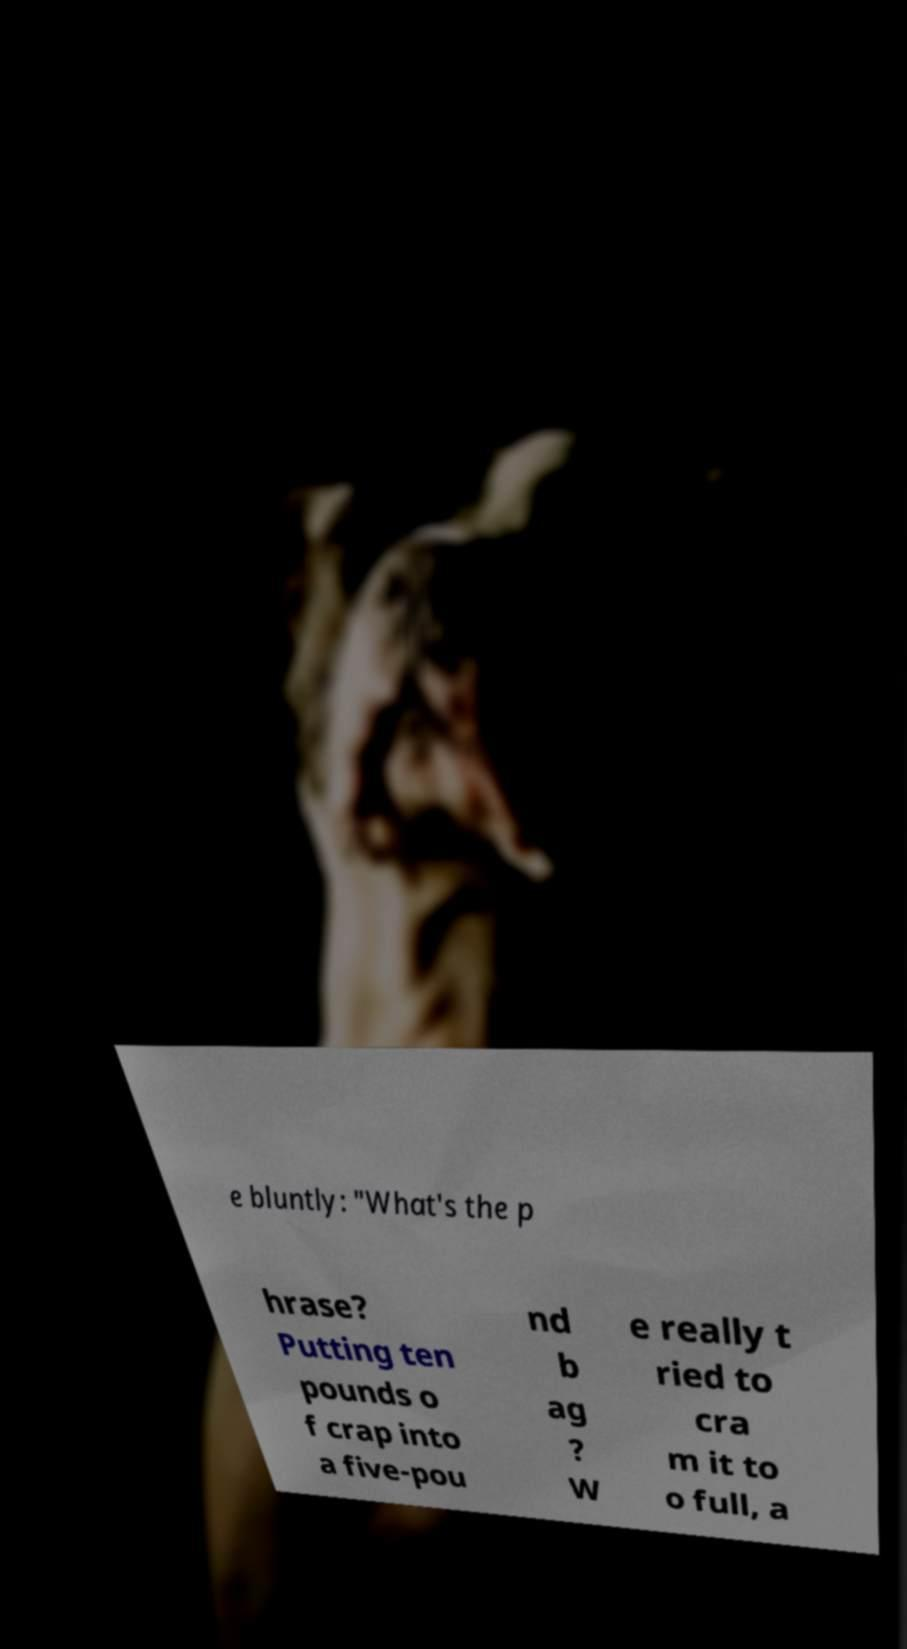Please identify and transcribe the text found in this image. e bluntly: "What's the p hrase? Putting ten pounds o f crap into a five-pou nd b ag ? W e really t ried to cra m it to o full, a 